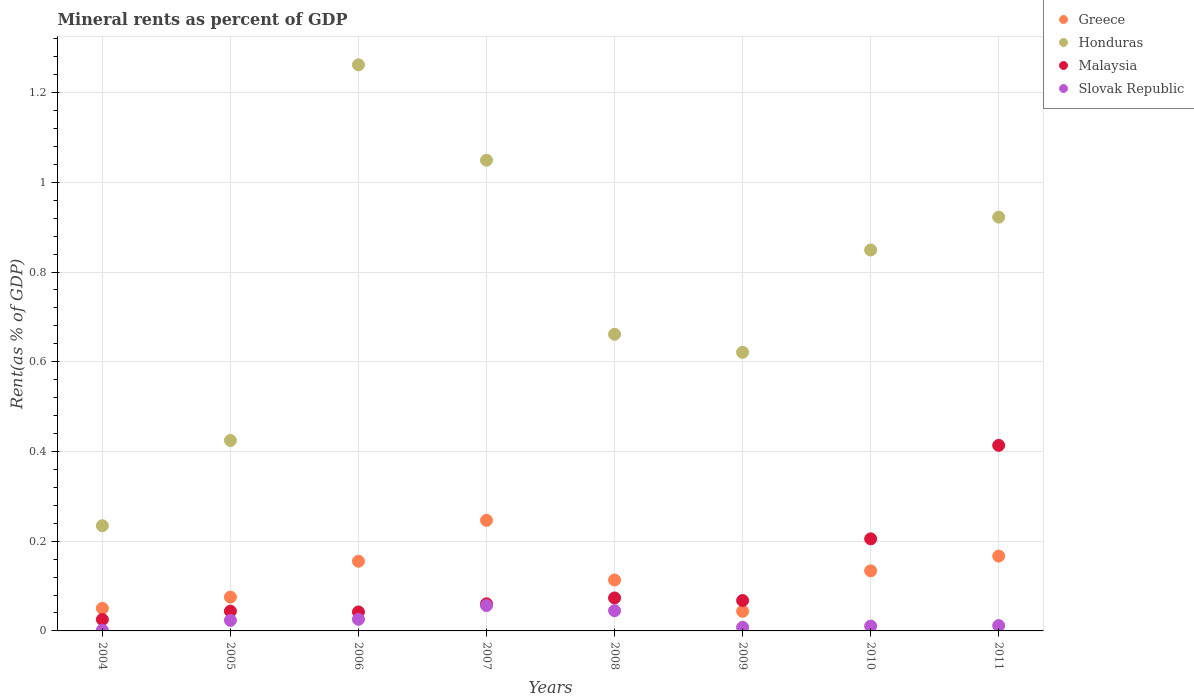How many different coloured dotlines are there?
Provide a succinct answer. 4. What is the mineral rent in Slovak Republic in 2009?
Offer a terse response. 0.01. Across all years, what is the maximum mineral rent in Greece?
Ensure brevity in your answer.  0.25. Across all years, what is the minimum mineral rent in Greece?
Offer a terse response. 0.04. In which year was the mineral rent in Slovak Republic minimum?
Give a very brief answer. 2004. What is the total mineral rent in Slovak Republic in the graph?
Your answer should be very brief. 0.18. What is the difference between the mineral rent in Honduras in 2004 and that in 2006?
Provide a short and direct response. -1.03. What is the difference between the mineral rent in Malaysia in 2011 and the mineral rent in Greece in 2005?
Your answer should be compact. 0.34. What is the average mineral rent in Honduras per year?
Keep it short and to the point. 0.75. In the year 2005, what is the difference between the mineral rent in Slovak Republic and mineral rent in Malaysia?
Provide a short and direct response. -0.02. What is the ratio of the mineral rent in Honduras in 2005 to that in 2007?
Offer a terse response. 0.4. Is the mineral rent in Malaysia in 2004 less than that in 2011?
Give a very brief answer. Yes. Is the difference between the mineral rent in Slovak Republic in 2008 and 2011 greater than the difference between the mineral rent in Malaysia in 2008 and 2011?
Keep it short and to the point. Yes. What is the difference between the highest and the second highest mineral rent in Honduras?
Your answer should be compact. 0.21. What is the difference between the highest and the lowest mineral rent in Malaysia?
Give a very brief answer. 0.39. Is it the case that in every year, the sum of the mineral rent in Malaysia and mineral rent in Slovak Republic  is greater than the sum of mineral rent in Greece and mineral rent in Honduras?
Keep it short and to the point. No. Does the mineral rent in Greece monotonically increase over the years?
Your response must be concise. No. Is the mineral rent in Greece strictly less than the mineral rent in Honduras over the years?
Provide a succinct answer. Yes. How many dotlines are there?
Provide a short and direct response. 4. What is the difference between two consecutive major ticks on the Y-axis?
Offer a terse response. 0.2. Are the values on the major ticks of Y-axis written in scientific E-notation?
Your response must be concise. No. Does the graph contain any zero values?
Provide a short and direct response. No. Does the graph contain grids?
Provide a short and direct response. Yes. Where does the legend appear in the graph?
Provide a succinct answer. Top right. How are the legend labels stacked?
Your answer should be very brief. Vertical. What is the title of the graph?
Provide a short and direct response. Mineral rents as percent of GDP. Does "Iran" appear as one of the legend labels in the graph?
Keep it short and to the point. No. What is the label or title of the Y-axis?
Give a very brief answer. Rent(as % of GDP). What is the Rent(as % of GDP) in Greece in 2004?
Your answer should be very brief. 0.05. What is the Rent(as % of GDP) in Honduras in 2004?
Give a very brief answer. 0.23. What is the Rent(as % of GDP) in Malaysia in 2004?
Provide a short and direct response. 0.03. What is the Rent(as % of GDP) of Slovak Republic in 2004?
Provide a short and direct response. 0. What is the Rent(as % of GDP) in Greece in 2005?
Your response must be concise. 0.08. What is the Rent(as % of GDP) in Honduras in 2005?
Offer a very short reply. 0.42. What is the Rent(as % of GDP) of Malaysia in 2005?
Provide a short and direct response. 0.04. What is the Rent(as % of GDP) in Slovak Republic in 2005?
Provide a succinct answer. 0.02. What is the Rent(as % of GDP) of Greece in 2006?
Keep it short and to the point. 0.16. What is the Rent(as % of GDP) in Honduras in 2006?
Give a very brief answer. 1.26. What is the Rent(as % of GDP) of Malaysia in 2006?
Your answer should be compact. 0.04. What is the Rent(as % of GDP) of Slovak Republic in 2006?
Provide a short and direct response. 0.03. What is the Rent(as % of GDP) of Greece in 2007?
Your answer should be compact. 0.25. What is the Rent(as % of GDP) in Honduras in 2007?
Provide a succinct answer. 1.05. What is the Rent(as % of GDP) of Malaysia in 2007?
Your response must be concise. 0.06. What is the Rent(as % of GDP) of Slovak Republic in 2007?
Offer a very short reply. 0.06. What is the Rent(as % of GDP) of Greece in 2008?
Give a very brief answer. 0.11. What is the Rent(as % of GDP) of Honduras in 2008?
Your answer should be very brief. 0.66. What is the Rent(as % of GDP) in Malaysia in 2008?
Ensure brevity in your answer.  0.07. What is the Rent(as % of GDP) in Slovak Republic in 2008?
Keep it short and to the point. 0.05. What is the Rent(as % of GDP) in Greece in 2009?
Your answer should be very brief. 0.04. What is the Rent(as % of GDP) in Honduras in 2009?
Your response must be concise. 0.62. What is the Rent(as % of GDP) of Malaysia in 2009?
Provide a succinct answer. 0.07. What is the Rent(as % of GDP) in Slovak Republic in 2009?
Your answer should be very brief. 0.01. What is the Rent(as % of GDP) of Greece in 2010?
Ensure brevity in your answer.  0.13. What is the Rent(as % of GDP) in Honduras in 2010?
Give a very brief answer. 0.85. What is the Rent(as % of GDP) of Malaysia in 2010?
Provide a succinct answer. 0.21. What is the Rent(as % of GDP) in Slovak Republic in 2010?
Your response must be concise. 0.01. What is the Rent(as % of GDP) of Greece in 2011?
Give a very brief answer. 0.17. What is the Rent(as % of GDP) of Honduras in 2011?
Offer a very short reply. 0.92. What is the Rent(as % of GDP) of Malaysia in 2011?
Your answer should be compact. 0.41. What is the Rent(as % of GDP) of Slovak Republic in 2011?
Make the answer very short. 0.01. Across all years, what is the maximum Rent(as % of GDP) of Greece?
Offer a terse response. 0.25. Across all years, what is the maximum Rent(as % of GDP) of Honduras?
Ensure brevity in your answer.  1.26. Across all years, what is the maximum Rent(as % of GDP) in Malaysia?
Your answer should be compact. 0.41. Across all years, what is the maximum Rent(as % of GDP) in Slovak Republic?
Provide a succinct answer. 0.06. Across all years, what is the minimum Rent(as % of GDP) in Greece?
Your response must be concise. 0.04. Across all years, what is the minimum Rent(as % of GDP) of Honduras?
Keep it short and to the point. 0.23. Across all years, what is the minimum Rent(as % of GDP) of Malaysia?
Your answer should be very brief. 0.03. Across all years, what is the minimum Rent(as % of GDP) of Slovak Republic?
Keep it short and to the point. 0. What is the total Rent(as % of GDP) in Greece in the graph?
Ensure brevity in your answer.  0.99. What is the total Rent(as % of GDP) in Honduras in the graph?
Provide a short and direct response. 6.02. What is the total Rent(as % of GDP) of Malaysia in the graph?
Your answer should be compact. 0.93. What is the total Rent(as % of GDP) in Slovak Republic in the graph?
Provide a short and direct response. 0.18. What is the difference between the Rent(as % of GDP) of Greece in 2004 and that in 2005?
Offer a terse response. -0.03. What is the difference between the Rent(as % of GDP) of Honduras in 2004 and that in 2005?
Offer a very short reply. -0.19. What is the difference between the Rent(as % of GDP) of Malaysia in 2004 and that in 2005?
Offer a very short reply. -0.02. What is the difference between the Rent(as % of GDP) of Slovak Republic in 2004 and that in 2005?
Give a very brief answer. -0.02. What is the difference between the Rent(as % of GDP) of Greece in 2004 and that in 2006?
Provide a short and direct response. -0.1. What is the difference between the Rent(as % of GDP) in Honduras in 2004 and that in 2006?
Offer a terse response. -1.03. What is the difference between the Rent(as % of GDP) in Malaysia in 2004 and that in 2006?
Make the answer very short. -0.02. What is the difference between the Rent(as % of GDP) in Slovak Republic in 2004 and that in 2006?
Keep it short and to the point. -0.02. What is the difference between the Rent(as % of GDP) of Greece in 2004 and that in 2007?
Give a very brief answer. -0.2. What is the difference between the Rent(as % of GDP) in Honduras in 2004 and that in 2007?
Offer a very short reply. -0.81. What is the difference between the Rent(as % of GDP) of Malaysia in 2004 and that in 2007?
Offer a very short reply. -0.04. What is the difference between the Rent(as % of GDP) in Slovak Republic in 2004 and that in 2007?
Your answer should be very brief. -0.06. What is the difference between the Rent(as % of GDP) of Greece in 2004 and that in 2008?
Keep it short and to the point. -0.06. What is the difference between the Rent(as % of GDP) in Honduras in 2004 and that in 2008?
Offer a terse response. -0.43. What is the difference between the Rent(as % of GDP) of Malaysia in 2004 and that in 2008?
Your answer should be very brief. -0.05. What is the difference between the Rent(as % of GDP) of Slovak Republic in 2004 and that in 2008?
Provide a succinct answer. -0.04. What is the difference between the Rent(as % of GDP) in Greece in 2004 and that in 2009?
Offer a terse response. 0.01. What is the difference between the Rent(as % of GDP) of Honduras in 2004 and that in 2009?
Give a very brief answer. -0.39. What is the difference between the Rent(as % of GDP) of Malaysia in 2004 and that in 2009?
Keep it short and to the point. -0.04. What is the difference between the Rent(as % of GDP) in Slovak Republic in 2004 and that in 2009?
Offer a very short reply. -0.01. What is the difference between the Rent(as % of GDP) in Greece in 2004 and that in 2010?
Offer a terse response. -0.08. What is the difference between the Rent(as % of GDP) in Honduras in 2004 and that in 2010?
Provide a succinct answer. -0.61. What is the difference between the Rent(as % of GDP) of Malaysia in 2004 and that in 2010?
Your answer should be compact. -0.18. What is the difference between the Rent(as % of GDP) in Slovak Republic in 2004 and that in 2010?
Your answer should be very brief. -0.01. What is the difference between the Rent(as % of GDP) in Greece in 2004 and that in 2011?
Provide a short and direct response. -0.12. What is the difference between the Rent(as % of GDP) in Honduras in 2004 and that in 2011?
Keep it short and to the point. -0.69. What is the difference between the Rent(as % of GDP) of Malaysia in 2004 and that in 2011?
Give a very brief answer. -0.39. What is the difference between the Rent(as % of GDP) of Slovak Republic in 2004 and that in 2011?
Provide a succinct answer. -0.01. What is the difference between the Rent(as % of GDP) in Greece in 2005 and that in 2006?
Your response must be concise. -0.08. What is the difference between the Rent(as % of GDP) in Honduras in 2005 and that in 2006?
Your answer should be very brief. -0.84. What is the difference between the Rent(as % of GDP) of Malaysia in 2005 and that in 2006?
Give a very brief answer. 0. What is the difference between the Rent(as % of GDP) of Slovak Republic in 2005 and that in 2006?
Provide a succinct answer. -0. What is the difference between the Rent(as % of GDP) in Greece in 2005 and that in 2007?
Make the answer very short. -0.17. What is the difference between the Rent(as % of GDP) of Honduras in 2005 and that in 2007?
Ensure brevity in your answer.  -0.62. What is the difference between the Rent(as % of GDP) of Malaysia in 2005 and that in 2007?
Provide a succinct answer. -0.02. What is the difference between the Rent(as % of GDP) in Slovak Republic in 2005 and that in 2007?
Your answer should be compact. -0.03. What is the difference between the Rent(as % of GDP) in Greece in 2005 and that in 2008?
Keep it short and to the point. -0.04. What is the difference between the Rent(as % of GDP) of Honduras in 2005 and that in 2008?
Your answer should be very brief. -0.24. What is the difference between the Rent(as % of GDP) in Malaysia in 2005 and that in 2008?
Offer a terse response. -0.03. What is the difference between the Rent(as % of GDP) of Slovak Republic in 2005 and that in 2008?
Your answer should be very brief. -0.02. What is the difference between the Rent(as % of GDP) in Greece in 2005 and that in 2009?
Provide a short and direct response. 0.03. What is the difference between the Rent(as % of GDP) in Honduras in 2005 and that in 2009?
Ensure brevity in your answer.  -0.2. What is the difference between the Rent(as % of GDP) of Malaysia in 2005 and that in 2009?
Offer a very short reply. -0.02. What is the difference between the Rent(as % of GDP) of Slovak Republic in 2005 and that in 2009?
Make the answer very short. 0.02. What is the difference between the Rent(as % of GDP) in Greece in 2005 and that in 2010?
Keep it short and to the point. -0.06. What is the difference between the Rent(as % of GDP) of Honduras in 2005 and that in 2010?
Your answer should be very brief. -0.42. What is the difference between the Rent(as % of GDP) in Malaysia in 2005 and that in 2010?
Your answer should be very brief. -0.16. What is the difference between the Rent(as % of GDP) in Slovak Republic in 2005 and that in 2010?
Your answer should be compact. 0.01. What is the difference between the Rent(as % of GDP) in Greece in 2005 and that in 2011?
Provide a short and direct response. -0.09. What is the difference between the Rent(as % of GDP) in Honduras in 2005 and that in 2011?
Offer a very short reply. -0.5. What is the difference between the Rent(as % of GDP) in Malaysia in 2005 and that in 2011?
Your response must be concise. -0.37. What is the difference between the Rent(as % of GDP) in Slovak Republic in 2005 and that in 2011?
Your answer should be compact. 0.01. What is the difference between the Rent(as % of GDP) in Greece in 2006 and that in 2007?
Make the answer very short. -0.09. What is the difference between the Rent(as % of GDP) in Honduras in 2006 and that in 2007?
Provide a succinct answer. 0.21. What is the difference between the Rent(as % of GDP) in Malaysia in 2006 and that in 2007?
Ensure brevity in your answer.  -0.02. What is the difference between the Rent(as % of GDP) in Slovak Republic in 2006 and that in 2007?
Provide a succinct answer. -0.03. What is the difference between the Rent(as % of GDP) in Greece in 2006 and that in 2008?
Provide a short and direct response. 0.04. What is the difference between the Rent(as % of GDP) in Honduras in 2006 and that in 2008?
Ensure brevity in your answer.  0.6. What is the difference between the Rent(as % of GDP) in Malaysia in 2006 and that in 2008?
Ensure brevity in your answer.  -0.03. What is the difference between the Rent(as % of GDP) of Slovak Republic in 2006 and that in 2008?
Your answer should be compact. -0.02. What is the difference between the Rent(as % of GDP) of Greece in 2006 and that in 2009?
Ensure brevity in your answer.  0.11. What is the difference between the Rent(as % of GDP) in Honduras in 2006 and that in 2009?
Your response must be concise. 0.64. What is the difference between the Rent(as % of GDP) of Malaysia in 2006 and that in 2009?
Provide a succinct answer. -0.03. What is the difference between the Rent(as % of GDP) of Slovak Republic in 2006 and that in 2009?
Ensure brevity in your answer.  0.02. What is the difference between the Rent(as % of GDP) of Greece in 2006 and that in 2010?
Provide a succinct answer. 0.02. What is the difference between the Rent(as % of GDP) in Honduras in 2006 and that in 2010?
Provide a succinct answer. 0.41. What is the difference between the Rent(as % of GDP) in Malaysia in 2006 and that in 2010?
Make the answer very short. -0.16. What is the difference between the Rent(as % of GDP) in Slovak Republic in 2006 and that in 2010?
Your response must be concise. 0.02. What is the difference between the Rent(as % of GDP) of Greece in 2006 and that in 2011?
Give a very brief answer. -0.01. What is the difference between the Rent(as % of GDP) of Honduras in 2006 and that in 2011?
Your response must be concise. 0.34. What is the difference between the Rent(as % of GDP) in Malaysia in 2006 and that in 2011?
Your response must be concise. -0.37. What is the difference between the Rent(as % of GDP) in Slovak Republic in 2006 and that in 2011?
Offer a terse response. 0.01. What is the difference between the Rent(as % of GDP) in Greece in 2007 and that in 2008?
Provide a short and direct response. 0.13. What is the difference between the Rent(as % of GDP) of Honduras in 2007 and that in 2008?
Provide a succinct answer. 0.39. What is the difference between the Rent(as % of GDP) of Malaysia in 2007 and that in 2008?
Keep it short and to the point. -0.01. What is the difference between the Rent(as % of GDP) in Slovak Republic in 2007 and that in 2008?
Offer a terse response. 0.01. What is the difference between the Rent(as % of GDP) in Greece in 2007 and that in 2009?
Offer a very short reply. 0.2. What is the difference between the Rent(as % of GDP) in Honduras in 2007 and that in 2009?
Give a very brief answer. 0.43. What is the difference between the Rent(as % of GDP) of Malaysia in 2007 and that in 2009?
Your response must be concise. -0.01. What is the difference between the Rent(as % of GDP) in Slovak Republic in 2007 and that in 2009?
Your response must be concise. 0.05. What is the difference between the Rent(as % of GDP) of Greece in 2007 and that in 2010?
Your answer should be very brief. 0.11. What is the difference between the Rent(as % of GDP) of Honduras in 2007 and that in 2010?
Provide a short and direct response. 0.2. What is the difference between the Rent(as % of GDP) of Malaysia in 2007 and that in 2010?
Make the answer very short. -0.14. What is the difference between the Rent(as % of GDP) in Slovak Republic in 2007 and that in 2010?
Provide a succinct answer. 0.05. What is the difference between the Rent(as % of GDP) of Greece in 2007 and that in 2011?
Make the answer very short. 0.08. What is the difference between the Rent(as % of GDP) of Honduras in 2007 and that in 2011?
Provide a short and direct response. 0.13. What is the difference between the Rent(as % of GDP) of Malaysia in 2007 and that in 2011?
Offer a terse response. -0.35. What is the difference between the Rent(as % of GDP) in Slovak Republic in 2007 and that in 2011?
Provide a succinct answer. 0.04. What is the difference between the Rent(as % of GDP) in Greece in 2008 and that in 2009?
Your response must be concise. 0.07. What is the difference between the Rent(as % of GDP) of Honduras in 2008 and that in 2009?
Provide a succinct answer. 0.04. What is the difference between the Rent(as % of GDP) of Malaysia in 2008 and that in 2009?
Offer a terse response. 0.01. What is the difference between the Rent(as % of GDP) in Slovak Republic in 2008 and that in 2009?
Your answer should be compact. 0.04. What is the difference between the Rent(as % of GDP) in Greece in 2008 and that in 2010?
Your answer should be very brief. -0.02. What is the difference between the Rent(as % of GDP) in Honduras in 2008 and that in 2010?
Offer a terse response. -0.19. What is the difference between the Rent(as % of GDP) in Malaysia in 2008 and that in 2010?
Offer a terse response. -0.13. What is the difference between the Rent(as % of GDP) of Slovak Republic in 2008 and that in 2010?
Provide a succinct answer. 0.03. What is the difference between the Rent(as % of GDP) of Greece in 2008 and that in 2011?
Offer a terse response. -0.05. What is the difference between the Rent(as % of GDP) in Honduras in 2008 and that in 2011?
Your answer should be very brief. -0.26. What is the difference between the Rent(as % of GDP) of Malaysia in 2008 and that in 2011?
Provide a short and direct response. -0.34. What is the difference between the Rent(as % of GDP) in Greece in 2009 and that in 2010?
Make the answer very short. -0.09. What is the difference between the Rent(as % of GDP) in Honduras in 2009 and that in 2010?
Provide a short and direct response. -0.23. What is the difference between the Rent(as % of GDP) of Malaysia in 2009 and that in 2010?
Your answer should be very brief. -0.14. What is the difference between the Rent(as % of GDP) in Slovak Republic in 2009 and that in 2010?
Ensure brevity in your answer.  -0. What is the difference between the Rent(as % of GDP) in Greece in 2009 and that in 2011?
Your answer should be compact. -0.12. What is the difference between the Rent(as % of GDP) in Honduras in 2009 and that in 2011?
Your answer should be very brief. -0.3. What is the difference between the Rent(as % of GDP) of Malaysia in 2009 and that in 2011?
Offer a very short reply. -0.35. What is the difference between the Rent(as % of GDP) in Slovak Republic in 2009 and that in 2011?
Provide a short and direct response. -0. What is the difference between the Rent(as % of GDP) in Greece in 2010 and that in 2011?
Your response must be concise. -0.03. What is the difference between the Rent(as % of GDP) in Honduras in 2010 and that in 2011?
Your answer should be compact. -0.07. What is the difference between the Rent(as % of GDP) in Malaysia in 2010 and that in 2011?
Offer a very short reply. -0.21. What is the difference between the Rent(as % of GDP) in Slovak Republic in 2010 and that in 2011?
Ensure brevity in your answer.  -0. What is the difference between the Rent(as % of GDP) of Greece in 2004 and the Rent(as % of GDP) of Honduras in 2005?
Provide a short and direct response. -0.37. What is the difference between the Rent(as % of GDP) in Greece in 2004 and the Rent(as % of GDP) in Malaysia in 2005?
Provide a succinct answer. 0.01. What is the difference between the Rent(as % of GDP) of Greece in 2004 and the Rent(as % of GDP) of Slovak Republic in 2005?
Your answer should be compact. 0.03. What is the difference between the Rent(as % of GDP) of Honduras in 2004 and the Rent(as % of GDP) of Malaysia in 2005?
Give a very brief answer. 0.19. What is the difference between the Rent(as % of GDP) of Honduras in 2004 and the Rent(as % of GDP) of Slovak Republic in 2005?
Offer a very short reply. 0.21. What is the difference between the Rent(as % of GDP) of Malaysia in 2004 and the Rent(as % of GDP) of Slovak Republic in 2005?
Your response must be concise. 0. What is the difference between the Rent(as % of GDP) of Greece in 2004 and the Rent(as % of GDP) of Honduras in 2006?
Provide a succinct answer. -1.21. What is the difference between the Rent(as % of GDP) of Greece in 2004 and the Rent(as % of GDP) of Malaysia in 2006?
Your response must be concise. 0.01. What is the difference between the Rent(as % of GDP) in Greece in 2004 and the Rent(as % of GDP) in Slovak Republic in 2006?
Ensure brevity in your answer.  0.02. What is the difference between the Rent(as % of GDP) of Honduras in 2004 and the Rent(as % of GDP) of Malaysia in 2006?
Your answer should be compact. 0.19. What is the difference between the Rent(as % of GDP) in Honduras in 2004 and the Rent(as % of GDP) in Slovak Republic in 2006?
Offer a very short reply. 0.21. What is the difference between the Rent(as % of GDP) of Malaysia in 2004 and the Rent(as % of GDP) of Slovak Republic in 2006?
Keep it short and to the point. -0. What is the difference between the Rent(as % of GDP) of Greece in 2004 and the Rent(as % of GDP) of Honduras in 2007?
Your answer should be compact. -1. What is the difference between the Rent(as % of GDP) of Greece in 2004 and the Rent(as % of GDP) of Malaysia in 2007?
Offer a very short reply. -0.01. What is the difference between the Rent(as % of GDP) in Greece in 2004 and the Rent(as % of GDP) in Slovak Republic in 2007?
Your answer should be compact. -0.01. What is the difference between the Rent(as % of GDP) of Honduras in 2004 and the Rent(as % of GDP) of Malaysia in 2007?
Offer a very short reply. 0.17. What is the difference between the Rent(as % of GDP) of Honduras in 2004 and the Rent(as % of GDP) of Slovak Republic in 2007?
Offer a very short reply. 0.18. What is the difference between the Rent(as % of GDP) of Malaysia in 2004 and the Rent(as % of GDP) of Slovak Republic in 2007?
Make the answer very short. -0.03. What is the difference between the Rent(as % of GDP) in Greece in 2004 and the Rent(as % of GDP) in Honduras in 2008?
Your response must be concise. -0.61. What is the difference between the Rent(as % of GDP) of Greece in 2004 and the Rent(as % of GDP) of Malaysia in 2008?
Give a very brief answer. -0.02. What is the difference between the Rent(as % of GDP) in Greece in 2004 and the Rent(as % of GDP) in Slovak Republic in 2008?
Offer a terse response. 0.01. What is the difference between the Rent(as % of GDP) of Honduras in 2004 and the Rent(as % of GDP) of Malaysia in 2008?
Offer a terse response. 0.16. What is the difference between the Rent(as % of GDP) in Honduras in 2004 and the Rent(as % of GDP) in Slovak Republic in 2008?
Your response must be concise. 0.19. What is the difference between the Rent(as % of GDP) in Malaysia in 2004 and the Rent(as % of GDP) in Slovak Republic in 2008?
Ensure brevity in your answer.  -0.02. What is the difference between the Rent(as % of GDP) of Greece in 2004 and the Rent(as % of GDP) of Honduras in 2009?
Give a very brief answer. -0.57. What is the difference between the Rent(as % of GDP) of Greece in 2004 and the Rent(as % of GDP) of Malaysia in 2009?
Offer a terse response. -0.02. What is the difference between the Rent(as % of GDP) in Greece in 2004 and the Rent(as % of GDP) in Slovak Republic in 2009?
Your answer should be very brief. 0.04. What is the difference between the Rent(as % of GDP) in Honduras in 2004 and the Rent(as % of GDP) in Malaysia in 2009?
Your answer should be compact. 0.17. What is the difference between the Rent(as % of GDP) in Honduras in 2004 and the Rent(as % of GDP) in Slovak Republic in 2009?
Your answer should be compact. 0.23. What is the difference between the Rent(as % of GDP) of Malaysia in 2004 and the Rent(as % of GDP) of Slovak Republic in 2009?
Provide a succinct answer. 0.02. What is the difference between the Rent(as % of GDP) in Greece in 2004 and the Rent(as % of GDP) in Honduras in 2010?
Offer a very short reply. -0.8. What is the difference between the Rent(as % of GDP) of Greece in 2004 and the Rent(as % of GDP) of Malaysia in 2010?
Your response must be concise. -0.15. What is the difference between the Rent(as % of GDP) in Greece in 2004 and the Rent(as % of GDP) in Slovak Republic in 2010?
Offer a terse response. 0.04. What is the difference between the Rent(as % of GDP) in Honduras in 2004 and the Rent(as % of GDP) in Malaysia in 2010?
Make the answer very short. 0.03. What is the difference between the Rent(as % of GDP) in Honduras in 2004 and the Rent(as % of GDP) in Slovak Republic in 2010?
Provide a short and direct response. 0.22. What is the difference between the Rent(as % of GDP) in Malaysia in 2004 and the Rent(as % of GDP) in Slovak Republic in 2010?
Offer a terse response. 0.01. What is the difference between the Rent(as % of GDP) in Greece in 2004 and the Rent(as % of GDP) in Honduras in 2011?
Provide a short and direct response. -0.87. What is the difference between the Rent(as % of GDP) of Greece in 2004 and the Rent(as % of GDP) of Malaysia in 2011?
Provide a succinct answer. -0.36. What is the difference between the Rent(as % of GDP) of Greece in 2004 and the Rent(as % of GDP) of Slovak Republic in 2011?
Ensure brevity in your answer.  0.04. What is the difference between the Rent(as % of GDP) in Honduras in 2004 and the Rent(as % of GDP) in Malaysia in 2011?
Your answer should be compact. -0.18. What is the difference between the Rent(as % of GDP) of Honduras in 2004 and the Rent(as % of GDP) of Slovak Republic in 2011?
Provide a succinct answer. 0.22. What is the difference between the Rent(as % of GDP) of Malaysia in 2004 and the Rent(as % of GDP) of Slovak Republic in 2011?
Provide a succinct answer. 0.01. What is the difference between the Rent(as % of GDP) of Greece in 2005 and the Rent(as % of GDP) of Honduras in 2006?
Your answer should be very brief. -1.19. What is the difference between the Rent(as % of GDP) of Greece in 2005 and the Rent(as % of GDP) of Malaysia in 2006?
Offer a terse response. 0.03. What is the difference between the Rent(as % of GDP) in Greece in 2005 and the Rent(as % of GDP) in Slovak Republic in 2006?
Your answer should be very brief. 0.05. What is the difference between the Rent(as % of GDP) in Honduras in 2005 and the Rent(as % of GDP) in Malaysia in 2006?
Offer a very short reply. 0.38. What is the difference between the Rent(as % of GDP) of Honduras in 2005 and the Rent(as % of GDP) of Slovak Republic in 2006?
Keep it short and to the point. 0.4. What is the difference between the Rent(as % of GDP) of Malaysia in 2005 and the Rent(as % of GDP) of Slovak Republic in 2006?
Provide a short and direct response. 0.02. What is the difference between the Rent(as % of GDP) of Greece in 2005 and the Rent(as % of GDP) of Honduras in 2007?
Your answer should be compact. -0.97. What is the difference between the Rent(as % of GDP) of Greece in 2005 and the Rent(as % of GDP) of Malaysia in 2007?
Your answer should be compact. 0.01. What is the difference between the Rent(as % of GDP) of Greece in 2005 and the Rent(as % of GDP) of Slovak Republic in 2007?
Your answer should be very brief. 0.02. What is the difference between the Rent(as % of GDP) in Honduras in 2005 and the Rent(as % of GDP) in Malaysia in 2007?
Offer a terse response. 0.36. What is the difference between the Rent(as % of GDP) in Honduras in 2005 and the Rent(as % of GDP) in Slovak Republic in 2007?
Your answer should be very brief. 0.37. What is the difference between the Rent(as % of GDP) of Malaysia in 2005 and the Rent(as % of GDP) of Slovak Republic in 2007?
Ensure brevity in your answer.  -0.01. What is the difference between the Rent(as % of GDP) of Greece in 2005 and the Rent(as % of GDP) of Honduras in 2008?
Keep it short and to the point. -0.59. What is the difference between the Rent(as % of GDP) of Greece in 2005 and the Rent(as % of GDP) of Malaysia in 2008?
Make the answer very short. 0. What is the difference between the Rent(as % of GDP) of Greece in 2005 and the Rent(as % of GDP) of Slovak Republic in 2008?
Provide a short and direct response. 0.03. What is the difference between the Rent(as % of GDP) in Honduras in 2005 and the Rent(as % of GDP) in Malaysia in 2008?
Ensure brevity in your answer.  0.35. What is the difference between the Rent(as % of GDP) of Honduras in 2005 and the Rent(as % of GDP) of Slovak Republic in 2008?
Ensure brevity in your answer.  0.38. What is the difference between the Rent(as % of GDP) in Malaysia in 2005 and the Rent(as % of GDP) in Slovak Republic in 2008?
Ensure brevity in your answer.  -0. What is the difference between the Rent(as % of GDP) of Greece in 2005 and the Rent(as % of GDP) of Honduras in 2009?
Your response must be concise. -0.55. What is the difference between the Rent(as % of GDP) of Greece in 2005 and the Rent(as % of GDP) of Malaysia in 2009?
Make the answer very short. 0.01. What is the difference between the Rent(as % of GDP) in Greece in 2005 and the Rent(as % of GDP) in Slovak Republic in 2009?
Offer a very short reply. 0.07. What is the difference between the Rent(as % of GDP) of Honduras in 2005 and the Rent(as % of GDP) of Malaysia in 2009?
Give a very brief answer. 0.36. What is the difference between the Rent(as % of GDP) of Honduras in 2005 and the Rent(as % of GDP) of Slovak Republic in 2009?
Your answer should be compact. 0.42. What is the difference between the Rent(as % of GDP) in Malaysia in 2005 and the Rent(as % of GDP) in Slovak Republic in 2009?
Make the answer very short. 0.04. What is the difference between the Rent(as % of GDP) in Greece in 2005 and the Rent(as % of GDP) in Honduras in 2010?
Give a very brief answer. -0.77. What is the difference between the Rent(as % of GDP) of Greece in 2005 and the Rent(as % of GDP) of Malaysia in 2010?
Your answer should be compact. -0.13. What is the difference between the Rent(as % of GDP) of Greece in 2005 and the Rent(as % of GDP) of Slovak Republic in 2010?
Your answer should be very brief. 0.06. What is the difference between the Rent(as % of GDP) of Honduras in 2005 and the Rent(as % of GDP) of Malaysia in 2010?
Provide a succinct answer. 0.22. What is the difference between the Rent(as % of GDP) in Honduras in 2005 and the Rent(as % of GDP) in Slovak Republic in 2010?
Offer a terse response. 0.41. What is the difference between the Rent(as % of GDP) of Malaysia in 2005 and the Rent(as % of GDP) of Slovak Republic in 2010?
Keep it short and to the point. 0.03. What is the difference between the Rent(as % of GDP) in Greece in 2005 and the Rent(as % of GDP) in Honduras in 2011?
Offer a terse response. -0.85. What is the difference between the Rent(as % of GDP) of Greece in 2005 and the Rent(as % of GDP) of Malaysia in 2011?
Your answer should be very brief. -0.34. What is the difference between the Rent(as % of GDP) in Greece in 2005 and the Rent(as % of GDP) in Slovak Republic in 2011?
Your answer should be very brief. 0.06. What is the difference between the Rent(as % of GDP) of Honduras in 2005 and the Rent(as % of GDP) of Malaysia in 2011?
Your response must be concise. 0.01. What is the difference between the Rent(as % of GDP) in Honduras in 2005 and the Rent(as % of GDP) in Slovak Republic in 2011?
Keep it short and to the point. 0.41. What is the difference between the Rent(as % of GDP) of Malaysia in 2005 and the Rent(as % of GDP) of Slovak Republic in 2011?
Offer a very short reply. 0.03. What is the difference between the Rent(as % of GDP) of Greece in 2006 and the Rent(as % of GDP) of Honduras in 2007?
Your answer should be very brief. -0.89. What is the difference between the Rent(as % of GDP) of Greece in 2006 and the Rent(as % of GDP) of Malaysia in 2007?
Provide a succinct answer. 0.09. What is the difference between the Rent(as % of GDP) of Greece in 2006 and the Rent(as % of GDP) of Slovak Republic in 2007?
Your answer should be very brief. 0.1. What is the difference between the Rent(as % of GDP) in Honduras in 2006 and the Rent(as % of GDP) in Malaysia in 2007?
Your answer should be very brief. 1.2. What is the difference between the Rent(as % of GDP) in Honduras in 2006 and the Rent(as % of GDP) in Slovak Republic in 2007?
Your answer should be very brief. 1.21. What is the difference between the Rent(as % of GDP) of Malaysia in 2006 and the Rent(as % of GDP) of Slovak Republic in 2007?
Ensure brevity in your answer.  -0.01. What is the difference between the Rent(as % of GDP) of Greece in 2006 and the Rent(as % of GDP) of Honduras in 2008?
Offer a very short reply. -0.51. What is the difference between the Rent(as % of GDP) in Greece in 2006 and the Rent(as % of GDP) in Malaysia in 2008?
Give a very brief answer. 0.08. What is the difference between the Rent(as % of GDP) of Greece in 2006 and the Rent(as % of GDP) of Slovak Republic in 2008?
Provide a short and direct response. 0.11. What is the difference between the Rent(as % of GDP) of Honduras in 2006 and the Rent(as % of GDP) of Malaysia in 2008?
Provide a succinct answer. 1.19. What is the difference between the Rent(as % of GDP) of Honduras in 2006 and the Rent(as % of GDP) of Slovak Republic in 2008?
Give a very brief answer. 1.22. What is the difference between the Rent(as % of GDP) in Malaysia in 2006 and the Rent(as % of GDP) in Slovak Republic in 2008?
Ensure brevity in your answer.  -0. What is the difference between the Rent(as % of GDP) of Greece in 2006 and the Rent(as % of GDP) of Honduras in 2009?
Offer a terse response. -0.47. What is the difference between the Rent(as % of GDP) of Greece in 2006 and the Rent(as % of GDP) of Malaysia in 2009?
Provide a short and direct response. 0.09. What is the difference between the Rent(as % of GDP) in Greece in 2006 and the Rent(as % of GDP) in Slovak Republic in 2009?
Give a very brief answer. 0.15. What is the difference between the Rent(as % of GDP) in Honduras in 2006 and the Rent(as % of GDP) in Malaysia in 2009?
Offer a very short reply. 1.19. What is the difference between the Rent(as % of GDP) of Honduras in 2006 and the Rent(as % of GDP) of Slovak Republic in 2009?
Offer a terse response. 1.25. What is the difference between the Rent(as % of GDP) of Malaysia in 2006 and the Rent(as % of GDP) of Slovak Republic in 2009?
Provide a succinct answer. 0.03. What is the difference between the Rent(as % of GDP) of Greece in 2006 and the Rent(as % of GDP) of Honduras in 2010?
Provide a succinct answer. -0.69. What is the difference between the Rent(as % of GDP) in Greece in 2006 and the Rent(as % of GDP) in Malaysia in 2010?
Provide a short and direct response. -0.05. What is the difference between the Rent(as % of GDP) in Greece in 2006 and the Rent(as % of GDP) in Slovak Republic in 2010?
Keep it short and to the point. 0.14. What is the difference between the Rent(as % of GDP) of Honduras in 2006 and the Rent(as % of GDP) of Malaysia in 2010?
Your answer should be compact. 1.06. What is the difference between the Rent(as % of GDP) in Honduras in 2006 and the Rent(as % of GDP) in Slovak Republic in 2010?
Provide a succinct answer. 1.25. What is the difference between the Rent(as % of GDP) in Malaysia in 2006 and the Rent(as % of GDP) in Slovak Republic in 2010?
Provide a succinct answer. 0.03. What is the difference between the Rent(as % of GDP) in Greece in 2006 and the Rent(as % of GDP) in Honduras in 2011?
Offer a terse response. -0.77. What is the difference between the Rent(as % of GDP) in Greece in 2006 and the Rent(as % of GDP) in Malaysia in 2011?
Your response must be concise. -0.26. What is the difference between the Rent(as % of GDP) in Greece in 2006 and the Rent(as % of GDP) in Slovak Republic in 2011?
Give a very brief answer. 0.14. What is the difference between the Rent(as % of GDP) in Honduras in 2006 and the Rent(as % of GDP) in Malaysia in 2011?
Offer a terse response. 0.85. What is the difference between the Rent(as % of GDP) of Malaysia in 2006 and the Rent(as % of GDP) of Slovak Republic in 2011?
Provide a succinct answer. 0.03. What is the difference between the Rent(as % of GDP) of Greece in 2007 and the Rent(as % of GDP) of Honduras in 2008?
Make the answer very short. -0.41. What is the difference between the Rent(as % of GDP) in Greece in 2007 and the Rent(as % of GDP) in Malaysia in 2008?
Make the answer very short. 0.17. What is the difference between the Rent(as % of GDP) of Greece in 2007 and the Rent(as % of GDP) of Slovak Republic in 2008?
Offer a very short reply. 0.2. What is the difference between the Rent(as % of GDP) in Honduras in 2007 and the Rent(as % of GDP) in Malaysia in 2008?
Give a very brief answer. 0.98. What is the difference between the Rent(as % of GDP) of Malaysia in 2007 and the Rent(as % of GDP) of Slovak Republic in 2008?
Your response must be concise. 0.02. What is the difference between the Rent(as % of GDP) in Greece in 2007 and the Rent(as % of GDP) in Honduras in 2009?
Provide a short and direct response. -0.37. What is the difference between the Rent(as % of GDP) in Greece in 2007 and the Rent(as % of GDP) in Malaysia in 2009?
Your answer should be very brief. 0.18. What is the difference between the Rent(as % of GDP) in Greece in 2007 and the Rent(as % of GDP) in Slovak Republic in 2009?
Keep it short and to the point. 0.24. What is the difference between the Rent(as % of GDP) of Honduras in 2007 and the Rent(as % of GDP) of Malaysia in 2009?
Offer a terse response. 0.98. What is the difference between the Rent(as % of GDP) of Honduras in 2007 and the Rent(as % of GDP) of Slovak Republic in 2009?
Keep it short and to the point. 1.04. What is the difference between the Rent(as % of GDP) of Malaysia in 2007 and the Rent(as % of GDP) of Slovak Republic in 2009?
Offer a very short reply. 0.05. What is the difference between the Rent(as % of GDP) of Greece in 2007 and the Rent(as % of GDP) of Honduras in 2010?
Your response must be concise. -0.6. What is the difference between the Rent(as % of GDP) in Greece in 2007 and the Rent(as % of GDP) in Malaysia in 2010?
Provide a succinct answer. 0.04. What is the difference between the Rent(as % of GDP) in Greece in 2007 and the Rent(as % of GDP) in Slovak Republic in 2010?
Offer a terse response. 0.24. What is the difference between the Rent(as % of GDP) of Honduras in 2007 and the Rent(as % of GDP) of Malaysia in 2010?
Make the answer very short. 0.84. What is the difference between the Rent(as % of GDP) in Honduras in 2007 and the Rent(as % of GDP) in Slovak Republic in 2010?
Your response must be concise. 1.04. What is the difference between the Rent(as % of GDP) in Malaysia in 2007 and the Rent(as % of GDP) in Slovak Republic in 2010?
Your answer should be compact. 0.05. What is the difference between the Rent(as % of GDP) in Greece in 2007 and the Rent(as % of GDP) in Honduras in 2011?
Your answer should be very brief. -0.68. What is the difference between the Rent(as % of GDP) in Greece in 2007 and the Rent(as % of GDP) in Malaysia in 2011?
Offer a terse response. -0.17. What is the difference between the Rent(as % of GDP) of Greece in 2007 and the Rent(as % of GDP) of Slovak Republic in 2011?
Keep it short and to the point. 0.23. What is the difference between the Rent(as % of GDP) in Honduras in 2007 and the Rent(as % of GDP) in Malaysia in 2011?
Provide a succinct answer. 0.64. What is the difference between the Rent(as % of GDP) of Honduras in 2007 and the Rent(as % of GDP) of Slovak Republic in 2011?
Provide a short and direct response. 1.04. What is the difference between the Rent(as % of GDP) of Malaysia in 2007 and the Rent(as % of GDP) of Slovak Republic in 2011?
Your response must be concise. 0.05. What is the difference between the Rent(as % of GDP) in Greece in 2008 and the Rent(as % of GDP) in Honduras in 2009?
Make the answer very short. -0.51. What is the difference between the Rent(as % of GDP) of Greece in 2008 and the Rent(as % of GDP) of Malaysia in 2009?
Your answer should be very brief. 0.05. What is the difference between the Rent(as % of GDP) in Greece in 2008 and the Rent(as % of GDP) in Slovak Republic in 2009?
Provide a succinct answer. 0.11. What is the difference between the Rent(as % of GDP) in Honduras in 2008 and the Rent(as % of GDP) in Malaysia in 2009?
Offer a terse response. 0.59. What is the difference between the Rent(as % of GDP) of Honduras in 2008 and the Rent(as % of GDP) of Slovak Republic in 2009?
Offer a terse response. 0.65. What is the difference between the Rent(as % of GDP) in Malaysia in 2008 and the Rent(as % of GDP) in Slovak Republic in 2009?
Make the answer very short. 0.07. What is the difference between the Rent(as % of GDP) in Greece in 2008 and the Rent(as % of GDP) in Honduras in 2010?
Offer a very short reply. -0.74. What is the difference between the Rent(as % of GDP) of Greece in 2008 and the Rent(as % of GDP) of Malaysia in 2010?
Give a very brief answer. -0.09. What is the difference between the Rent(as % of GDP) in Greece in 2008 and the Rent(as % of GDP) in Slovak Republic in 2010?
Your answer should be compact. 0.1. What is the difference between the Rent(as % of GDP) of Honduras in 2008 and the Rent(as % of GDP) of Malaysia in 2010?
Offer a terse response. 0.46. What is the difference between the Rent(as % of GDP) in Honduras in 2008 and the Rent(as % of GDP) in Slovak Republic in 2010?
Provide a succinct answer. 0.65. What is the difference between the Rent(as % of GDP) of Malaysia in 2008 and the Rent(as % of GDP) of Slovak Republic in 2010?
Give a very brief answer. 0.06. What is the difference between the Rent(as % of GDP) of Greece in 2008 and the Rent(as % of GDP) of Honduras in 2011?
Provide a succinct answer. -0.81. What is the difference between the Rent(as % of GDP) in Greece in 2008 and the Rent(as % of GDP) in Slovak Republic in 2011?
Keep it short and to the point. 0.1. What is the difference between the Rent(as % of GDP) in Honduras in 2008 and the Rent(as % of GDP) in Malaysia in 2011?
Your response must be concise. 0.25. What is the difference between the Rent(as % of GDP) of Honduras in 2008 and the Rent(as % of GDP) of Slovak Republic in 2011?
Give a very brief answer. 0.65. What is the difference between the Rent(as % of GDP) in Malaysia in 2008 and the Rent(as % of GDP) in Slovak Republic in 2011?
Your response must be concise. 0.06. What is the difference between the Rent(as % of GDP) of Greece in 2009 and the Rent(as % of GDP) of Honduras in 2010?
Give a very brief answer. -0.81. What is the difference between the Rent(as % of GDP) of Greece in 2009 and the Rent(as % of GDP) of Malaysia in 2010?
Provide a succinct answer. -0.16. What is the difference between the Rent(as % of GDP) of Greece in 2009 and the Rent(as % of GDP) of Slovak Republic in 2010?
Keep it short and to the point. 0.03. What is the difference between the Rent(as % of GDP) of Honduras in 2009 and the Rent(as % of GDP) of Malaysia in 2010?
Your answer should be compact. 0.42. What is the difference between the Rent(as % of GDP) of Honduras in 2009 and the Rent(as % of GDP) of Slovak Republic in 2010?
Ensure brevity in your answer.  0.61. What is the difference between the Rent(as % of GDP) of Malaysia in 2009 and the Rent(as % of GDP) of Slovak Republic in 2010?
Your answer should be very brief. 0.06. What is the difference between the Rent(as % of GDP) of Greece in 2009 and the Rent(as % of GDP) of Honduras in 2011?
Provide a succinct answer. -0.88. What is the difference between the Rent(as % of GDP) of Greece in 2009 and the Rent(as % of GDP) of Malaysia in 2011?
Offer a terse response. -0.37. What is the difference between the Rent(as % of GDP) of Greece in 2009 and the Rent(as % of GDP) of Slovak Republic in 2011?
Ensure brevity in your answer.  0.03. What is the difference between the Rent(as % of GDP) of Honduras in 2009 and the Rent(as % of GDP) of Malaysia in 2011?
Your answer should be very brief. 0.21. What is the difference between the Rent(as % of GDP) of Honduras in 2009 and the Rent(as % of GDP) of Slovak Republic in 2011?
Your response must be concise. 0.61. What is the difference between the Rent(as % of GDP) of Malaysia in 2009 and the Rent(as % of GDP) of Slovak Republic in 2011?
Provide a short and direct response. 0.06. What is the difference between the Rent(as % of GDP) of Greece in 2010 and the Rent(as % of GDP) of Honduras in 2011?
Your answer should be compact. -0.79. What is the difference between the Rent(as % of GDP) of Greece in 2010 and the Rent(as % of GDP) of Malaysia in 2011?
Offer a terse response. -0.28. What is the difference between the Rent(as % of GDP) of Greece in 2010 and the Rent(as % of GDP) of Slovak Republic in 2011?
Make the answer very short. 0.12. What is the difference between the Rent(as % of GDP) in Honduras in 2010 and the Rent(as % of GDP) in Malaysia in 2011?
Offer a very short reply. 0.44. What is the difference between the Rent(as % of GDP) of Honduras in 2010 and the Rent(as % of GDP) of Slovak Republic in 2011?
Offer a very short reply. 0.84. What is the difference between the Rent(as % of GDP) of Malaysia in 2010 and the Rent(as % of GDP) of Slovak Republic in 2011?
Ensure brevity in your answer.  0.19. What is the average Rent(as % of GDP) of Greece per year?
Offer a very short reply. 0.12. What is the average Rent(as % of GDP) in Honduras per year?
Keep it short and to the point. 0.75. What is the average Rent(as % of GDP) of Malaysia per year?
Your answer should be compact. 0.12. What is the average Rent(as % of GDP) of Slovak Republic per year?
Your answer should be very brief. 0.02. In the year 2004, what is the difference between the Rent(as % of GDP) of Greece and Rent(as % of GDP) of Honduras?
Keep it short and to the point. -0.18. In the year 2004, what is the difference between the Rent(as % of GDP) in Greece and Rent(as % of GDP) in Malaysia?
Give a very brief answer. 0.02. In the year 2004, what is the difference between the Rent(as % of GDP) in Greece and Rent(as % of GDP) in Slovak Republic?
Your response must be concise. 0.05. In the year 2004, what is the difference between the Rent(as % of GDP) in Honduras and Rent(as % of GDP) in Malaysia?
Keep it short and to the point. 0.21. In the year 2004, what is the difference between the Rent(as % of GDP) of Honduras and Rent(as % of GDP) of Slovak Republic?
Ensure brevity in your answer.  0.23. In the year 2004, what is the difference between the Rent(as % of GDP) in Malaysia and Rent(as % of GDP) in Slovak Republic?
Give a very brief answer. 0.02. In the year 2005, what is the difference between the Rent(as % of GDP) of Greece and Rent(as % of GDP) of Honduras?
Provide a short and direct response. -0.35. In the year 2005, what is the difference between the Rent(as % of GDP) in Greece and Rent(as % of GDP) in Malaysia?
Your answer should be compact. 0.03. In the year 2005, what is the difference between the Rent(as % of GDP) of Greece and Rent(as % of GDP) of Slovak Republic?
Your response must be concise. 0.05. In the year 2005, what is the difference between the Rent(as % of GDP) in Honduras and Rent(as % of GDP) in Malaysia?
Provide a short and direct response. 0.38. In the year 2005, what is the difference between the Rent(as % of GDP) in Honduras and Rent(as % of GDP) in Slovak Republic?
Offer a terse response. 0.4. In the year 2005, what is the difference between the Rent(as % of GDP) of Malaysia and Rent(as % of GDP) of Slovak Republic?
Provide a succinct answer. 0.02. In the year 2006, what is the difference between the Rent(as % of GDP) in Greece and Rent(as % of GDP) in Honduras?
Provide a short and direct response. -1.11. In the year 2006, what is the difference between the Rent(as % of GDP) in Greece and Rent(as % of GDP) in Malaysia?
Offer a terse response. 0.11. In the year 2006, what is the difference between the Rent(as % of GDP) in Greece and Rent(as % of GDP) in Slovak Republic?
Ensure brevity in your answer.  0.13. In the year 2006, what is the difference between the Rent(as % of GDP) in Honduras and Rent(as % of GDP) in Malaysia?
Ensure brevity in your answer.  1.22. In the year 2006, what is the difference between the Rent(as % of GDP) of Honduras and Rent(as % of GDP) of Slovak Republic?
Offer a terse response. 1.24. In the year 2006, what is the difference between the Rent(as % of GDP) of Malaysia and Rent(as % of GDP) of Slovak Republic?
Make the answer very short. 0.02. In the year 2007, what is the difference between the Rent(as % of GDP) of Greece and Rent(as % of GDP) of Honduras?
Give a very brief answer. -0.8. In the year 2007, what is the difference between the Rent(as % of GDP) in Greece and Rent(as % of GDP) in Malaysia?
Ensure brevity in your answer.  0.19. In the year 2007, what is the difference between the Rent(as % of GDP) in Greece and Rent(as % of GDP) in Slovak Republic?
Make the answer very short. 0.19. In the year 2007, what is the difference between the Rent(as % of GDP) in Honduras and Rent(as % of GDP) in Malaysia?
Provide a succinct answer. 0.99. In the year 2007, what is the difference between the Rent(as % of GDP) in Honduras and Rent(as % of GDP) in Slovak Republic?
Provide a short and direct response. 0.99. In the year 2007, what is the difference between the Rent(as % of GDP) in Malaysia and Rent(as % of GDP) in Slovak Republic?
Your response must be concise. 0. In the year 2008, what is the difference between the Rent(as % of GDP) of Greece and Rent(as % of GDP) of Honduras?
Give a very brief answer. -0.55. In the year 2008, what is the difference between the Rent(as % of GDP) in Greece and Rent(as % of GDP) in Malaysia?
Offer a terse response. 0.04. In the year 2008, what is the difference between the Rent(as % of GDP) in Greece and Rent(as % of GDP) in Slovak Republic?
Your response must be concise. 0.07. In the year 2008, what is the difference between the Rent(as % of GDP) of Honduras and Rent(as % of GDP) of Malaysia?
Your response must be concise. 0.59. In the year 2008, what is the difference between the Rent(as % of GDP) in Honduras and Rent(as % of GDP) in Slovak Republic?
Provide a succinct answer. 0.62. In the year 2008, what is the difference between the Rent(as % of GDP) of Malaysia and Rent(as % of GDP) of Slovak Republic?
Make the answer very short. 0.03. In the year 2009, what is the difference between the Rent(as % of GDP) of Greece and Rent(as % of GDP) of Honduras?
Your response must be concise. -0.58. In the year 2009, what is the difference between the Rent(as % of GDP) in Greece and Rent(as % of GDP) in Malaysia?
Ensure brevity in your answer.  -0.02. In the year 2009, what is the difference between the Rent(as % of GDP) in Greece and Rent(as % of GDP) in Slovak Republic?
Provide a succinct answer. 0.04. In the year 2009, what is the difference between the Rent(as % of GDP) in Honduras and Rent(as % of GDP) in Malaysia?
Provide a short and direct response. 0.55. In the year 2009, what is the difference between the Rent(as % of GDP) of Honduras and Rent(as % of GDP) of Slovak Republic?
Ensure brevity in your answer.  0.61. In the year 2009, what is the difference between the Rent(as % of GDP) of Malaysia and Rent(as % of GDP) of Slovak Republic?
Keep it short and to the point. 0.06. In the year 2010, what is the difference between the Rent(as % of GDP) of Greece and Rent(as % of GDP) of Honduras?
Make the answer very short. -0.72. In the year 2010, what is the difference between the Rent(as % of GDP) in Greece and Rent(as % of GDP) in Malaysia?
Your response must be concise. -0.07. In the year 2010, what is the difference between the Rent(as % of GDP) of Greece and Rent(as % of GDP) of Slovak Republic?
Your answer should be compact. 0.12. In the year 2010, what is the difference between the Rent(as % of GDP) in Honduras and Rent(as % of GDP) in Malaysia?
Make the answer very short. 0.64. In the year 2010, what is the difference between the Rent(as % of GDP) in Honduras and Rent(as % of GDP) in Slovak Republic?
Ensure brevity in your answer.  0.84. In the year 2010, what is the difference between the Rent(as % of GDP) in Malaysia and Rent(as % of GDP) in Slovak Republic?
Offer a very short reply. 0.19. In the year 2011, what is the difference between the Rent(as % of GDP) in Greece and Rent(as % of GDP) in Honduras?
Your response must be concise. -0.76. In the year 2011, what is the difference between the Rent(as % of GDP) in Greece and Rent(as % of GDP) in Malaysia?
Make the answer very short. -0.25. In the year 2011, what is the difference between the Rent(as % of GDP) in Greece and Rent(as % of GDP) in Slovak Republic?
Your answer should be very brief. 0.15. In the year 2011, what is the difference between the Rent(as % of GDP) of Honduras and Rent(as % of GDP) of Malaysia?
Ensure brevity in your answer.  0.51. In the year 2011, what is the difference between the Rent(as % of GDP) in Honduras and Rent(as % of GDP) in Slovak Republic?
Offer a terse response. 0.91. In the year 2011, what is the difference between the Rent(as % of GDP) of Malaysia and Rent(as % of GDP) of Slovak Republic?
Provide a succinct answer. 0.4. What is the ratio of the Rent(as % of GDP) in Greece in 2004 to that in 2005?
Your answer should be very brief. 0.67. What is the ratio of the Rent(as % of GDP) in Honduras in 2004 to that in 2005?
Provide a short and direct response. 0.55. What is the ratio of the Rent(as % of GDP) of Malaysia in 2004 to that in 2005?
Make the answer very short. 0.58. What is the ratio of the Rent(as % of GDP) of Slovak Republic in 2004 to that in 2005?
Offer a terse response. 0.06. What is the ratio of the Rent(as % of GDP) of Greece in 2004 to that in 2006?
Your answer should be compact. 0.32. What is the ratio of the Rent(as % of GDP) of Honduras in 2004 to that in 2006?
Give a very brief answer. 0.19. What is the ratio of the Rent(as % of GDP) of Malaysia in 2004 to that in 2006?
Your response must be concise. 0.6. What is the ratio of the Rent(as % of GDP) in Slovak Republic in 2004 to that in 2006?
Ensure brevity in your answer.  0.06. What is the ratio of the Rent(as % of GDP) of Greece in 2004 to that in 2007?
Ensure brevity in your answer.  0.2. What is the ratio of the Rent(as % of GDP) of Honduras in 2004 to that in 2007?
Your answer should be very brief. 0.22. What is the ratio of the Rent(as % of GDP) of Malaysia in 2004 to that in 2007?
Your answer should be very brief. 0.42. What is the ratio of the Rent(as % of GDP) of Slovak Republic in 2004 to that in 2007?
Your response must be concise. 0.03. What is the ratio of the Rent(as % of GDP) of Greece in 2004 to that in 2008?
Your answer should be compact. 0.44. What is the ratio of the Rent(as % of GDP) in Honduras in 2004 to that in 2008?
Your response must be concise. 0.35. What is the ratio of the Rent(as % of GDP) of Malaysia in 2004 to that in 2008?
Ensure brevity in your answer.  0.35. What is the ratio of the Rent(as % of GDP) of Slovak Republic in 2004 to that in 2008?
Make the answer very short. 0.03. What is the ratio of the Rent(as % of GDP) of Greece in 2004 to that in 2009?
Provide a succinct answer. 1.15. What is the ratio of the Rent(as % of GDP) of Honduras in 2004 to that in 2009?
Provide a succinct answer. 0.38. What is the ratio of the Rent(as % of GDP) of Malaysia in 2004 to that in 2009?
Give a very brief answer. 0.37. What is the ratio of the Rent(as % of GDP) of Slovak Republic in 2004 to that in 2009?
Your answer should be compact. 0.18. What is the ratio of the Rent(as % of GDP) in Greece in 2004 to that in 2010?
Give a very brief answer. 0.38. What is the ratio of the Rent(as % of GDP) of Honduras in 2004 to that in 2010?
Make the answer very short. 0.28. What is the ratio of the Rent(as % of GDP) of Malaysia in 2004 to that in 2010?
Keep it short and to the point. 0.12. What is the ratio of the Rent(as % of GDP) in Slovak Republic in 2004 to that in 2010?
Ensure brevity in your answer.  0.14. What is the ratio of the Rent(as % of GDP) in Greece in 2004 to that in 2011?
Make the answer very short. 0.3. What is the ratio of the Rent(as % of GDP) of Honduras in 2004 to that in 2011?
Your response must be concise. 0.25. What is the ratio of the Rent(as % of GDP) of Malaysia in 2004 to that in 2011?
Offer a very short reply. 0.06. What is the ratio of the Rent(as % of GDP) of Slovak Republic in 2004 to that in 2011?
Offer a very short reply. 0.12. What is the ratio of the Rent(as % of GDP) in Greece in 2005 to that in 2006?
Ensure brevity in your answer.  0.49. What is the ratio of the Rent(as % of GDP) in Honduras in 2005 to that in 2006?
Your answer should be very brief. 0.34. What is the ratio of the Rent(as % of GDP) of Malaysia in 2005 to that in 2006?
Your answer should be very brief. 1.04. What is the ratio of the Rent(as % of GDP) of Slovak Republic in 2005 to that in 2006?
Give a very brief answer. 0.9. What is the ratio of the Rent(as % of GDP) of Greece in 2005 to that in 2007?
Make the answer very short. 0.31. What is the ratio of the Rent(as % of GDP) of Honduras in 2005 to that in 2007?
Provide a succinct answer. 0.4. What is the ratio of the Rent(as % of GDP) of Malaysia in 2005 to that in 2007?
Ensure brevity in your answer.  0.73. What is the ratio of the Rent(as % of GDP) in Slovak Republic in 2005 to that in 2007?
Keep it short and to the point. 0.42. What is the ratio of the Rent(as % of GDP) of Greece in 2005 to that in 2008?
Keep it short and to the point. 0.66. What is the ratio of the Rent(as % of GDP) in Honduras in 2005 to that in 2008?
Offer a very short reply. 0.64. What is the ratio of the Rent(as % of GDP) in Malaysia in 2005 to that in 2008?
Ensure brevity in your answer.  0.6. What is the ratio of the Rent(as % of GDP) in Slovak Republic in 2005 to that in 2008?
Give a very brief answer. 0.52. What is the ratio of the Rent(as % of GDP) of Greece in 2005 to that in 2009?
Your answer should be compact. 1.72. What is the ratio of the Rent(as % of GDP) in Honduras in 2005 to that in 2009?
Offer a very short reply. 0.68. What is the ratio of the Rent(as % of GDP) of Malaysia in 2005 to that in 2009?
Provide a succinct answer. 0.65. What is the ratio of the Rent(as % of GDP) of Slovak Republic in 2005 to that in 2009?
Your answer should be very brief. 2.93. What is the ratio of the Rent(as % of GDP) in Greece in 2005 to that in 2010?
Your response must be concise. 0.56. What is the ratio of the Rent(as % of GDP) of Malaysia in 2005 to that in 2010?
Provide a succinct answer. 0.21. What is the ratio of the Rent(as % of GDP) of Slovak Republic in 2005 to that in 2010?
Your answer should be very brief. 2.17. What is the ratio of the Rent(as % of GDP) in Greece in 2005 to that in 2011?
Provide a succinct answer. 0.45. What is the ratio of the Rent(as % of GDP) of Honduras in 2005 to that in 2011?
Your answer should be very brief. 0.46. What is the ratio of the Rent(as % of GDP) in Malaysia in 2005 to that in 2011?
Offer a terse response. 0.11. What is the ratio of the Rent(as % of GDP) of Slovak Republic in 2005 to that in 2011?
Keep it short and to the point. 1.99. What is the ratio of the Rent(as % of GDP) of Greece in 2006 to that in 2007?
Ensure brevity in your answer.  0.63. What is the ratio of the Rent(as % of GDP) of Honduras in 2006 to that in 2007?
Your answer should be very brief. 1.2. What is the ratio of the Rent(as % of GDP) in Malaysia in 2006 to that in 2007?
Make the answer very short. 0.7. What is the ratio of the Rent(as % of GDP) in Slovak Republic in 2006 to that in 2007?
Your answer should be very brief. 0.46. What is the ratio of the Rent(as % of GDP) in Greece in 2006 to that in 2008?
Your answer should be very brief. 1.37. What is the ratio of the Rent(as % of GDP) of Honduras in 2006 to that in 2008?
Keep it short and to the point. 1.91. What is the ratio of the Rent(as % of GDP) in Malaysia in 2006 to that in 2008?
Provide a short and direct response. 0.58. What is the ratio of the Rent(as % of GDP) in Slovak Republic in 2006 to that in 2008?
Your answer should be very brief. 0.57. What is the ratio of the Rent(as % of GDP) in Greece in 2006 to that in 2009?
Offer a very short reply. 3.55. What is the ratio of the Rent(as % of GDP) of Honduras in 2006 to that in 2009?
Your answer should be very brief. 2.03. What is the ratio of the Rent(as % of GDP) of Malaysia in 2006 to that in 2009?
Ensure brevity in your answer.  0.62. What is the ratio of the Rent(as % of GDP) of Slovak Republic in 2006 to that in 2009?
Provide a short and direct response. 3.23. What is the ratio of the Rent(as % of GDP) in Greece in 2006 to that in 2010?
Your answer should be very brief. 1.16. What is the ratio of the Rent(as % of GDP) of Honduras in 2006 to that in 2010?
Offer a very short reply. 1.49. What is the ratio of the Rent(as % of GDP) in Malaysia in 2006 to that in 2010?
Offer a terse response. 0.21. What is the ratio of the Rent(as % of GDP) in Slovak Republic in 2006 to that in 2010?
Provide a short and direct response. 2.4. What is the ratio of the Rent(as % of GDP) of Greece in 2006 to that in 2011?
Give a very brief answer. 0.93. What is the ratio of the Rent(as % of GDP) in Honduras in 2006 to that in 2011?
Provide a succinct answer. 1.37. What is the ratio of the Rent(as % of GDP) in Malaysia in 2006 to that in 2011?
Offer a very short reply. 0.1. What is the ratio of the Rent(as % of GDP) in Slovak Republic in 2006 to that in 2011?
Offer a very short reply. 2.2. What is the ratio of the Rent(as % of GDP) in Greece in 2007 to that in 2008?
Keep it short and to the point. 2.17. What is the ratio of the Rent(as % of GDP) in Honduras in 2007 to that in 2008?
Ensure brevity in your answer.  1.59. What is the ratio of the Rent(as % of GDP) of Malaysia in 2007 to that in 2008?
Your response must be concise. 0.82. What is the ratio of the Rent(as % of GDP) in Slovak Republic in 2007 to that in 2008?
Keep it short and to the point. 1.25. What is the ratio of the Rent(as % of GDP) in Greece in 2007 to that in 2009?
Your response must be concise. 5.64. What is the ratio of the Rent(as % of GDP) in Honduras in 2007 to that in 2009?
Offer a very short reply. 1.69. What is the ratio of the Rent(as % of GDP) of Malaysia in 2007 to that in 2009?
Make the answer very short. 0.89. What is the ratio of the Rent(as % of GDP) in Slovak Republic in 2007 to that in 2009?
Your answer should be compact. 7.05. What is the ratio of the Rent(as % of GDP) in Greece in 2007 to that in 2010?
Ensure brevity in your answer.  1.84. What is the ratio of the Rent(as % of GDP) of Honduras in 2007 to that in 2010?
Make the answer very short. 1.24. What is the ratio of the Rent(as % of GDP) of Malaysia in 2007 to that in 2010?
Keep it short and to the point. 0.29. What is the ratio of the Rent(as % of GDP) in Slovak Republic in 2007 to that in 2010?
Ensure brevity in your answer.  5.24. What is the ratio of the Rent(as % of GDP) of Greece in 2007 to that in 2011?
Offer a terse response. 1.48. What is the ratio of the Rent(as % of GDP) of Honduras in 2007 to that in 2011?
Provide a short and direct response. 1.14. What is the ratio of the Rent(as % of GDP) of Malaysia in 2007 to that in 2011?
Provide a succinct answer. 0.15. What is the ratio of the Rent(as % of GDP) of Slovak Republic in 2007 to that in 2011?
Provide a succinct answer. 4.79. What is the ratio of the Rent(as % of GDP) in Greece in 2008 to that in 2009?
Provide a succinct answer. 2.6. What is the ratio of the Rent(as % of GDP) in Honduras in 2008 to that in 2009?
Your answer should be compact. 1.06. What is the ratio of the Rent(as % of GDP) in Malaysia in 2008 to that in 2009?
Provide a succinct answer. 1.08. What is the ratio of the Rent(as % of GDP) of Slovak Republic in 2008 to that in 2009?
Give a very brief answer. 5.63. What is the ratio of the Rent(as % of GDP) of Greece in 2008 to that in 2010?
Provide a short and direct response. 0.85. What is the ratio of the Rent(as % of GDP) in Honduras in 2008 to that in 2010?
Your answer should be very brief. 0.78. What is the ratio of the Rent(as % of GDP) of Malaysia in 2008 to that in 2010?
Ensure brevity in your answer.  0.36. What is the ratio of the Rent(as % of GDP) of Slovak Republic in 2008 to that in 2010?
Offer a very short reply. 4.18. What is the ratio of the Rent(as % of GDP) in Greece in 2008 to that in 2011?
Offer a terse response. 0.68. What is the ratio of the Rent(as % of GDP) of Honduras in 2008 to that in 2011?
Your answer should be compact. 0.72. What is the ratio of the Rent(as % of GDP) in Malaysia in 2008 to that in 2011?
Your answer should be compact. 0.18. What is the ratio of the Rent(as % of GDP) in Slovak Republic in 2008 to that in 2011?
Offer a very short reply. 3.83. What is the ratio of the Rent(as % of GDP) in Greece in 2009 to that in 2010?
Make the answer very short. 0.33. What is the ratio of the Rent(as % of GDP) of Honduras in 2009 to that in 2010?
Give a very brief answer. 0.73. What is the ratio of the Rent(as % of GDP) in Malaysia in 2009 to that in 2010?
Your answer should be compact. 0.33. What is the ratio of the Rent(as % of GDP) of Slovak Republic in 2009 to that in 2010?
Your answer should be compact. 0.74. What is the ratio of the Rent(as % of GDP) in Greece in 2009 to that in 2011?
Keep it short and to the point. 0.26. What is the ratio of the Rent(as % of GDP) of Honduras in 2009 to that in 2011?
Your response must be concise. 0.67. What is the ratio of the Rent(as % of GDP) of Malaysia in 2009 to that in 2011?
Your response must be concise. 0.16. What is the ratio of the Rent(as % of GDP) of Slovak Republic in 2009 to that in 2011?
Your answer should be very brief. 0.68. What is the ratio of the Rent(as % of GDP) in Greece in 2010 to that in 2011?
Keep it short and to the point. 0.8. What is the ratio of the Rent(as % of GDP) in Honduras in 2010 to that in 2011?
Offer a terse response. 0.92. What is the ratio of the Rent(as % of GDP) in Malaysia in 2010 to that in 2011?
Your answer should be compact. 0.5. What is the ratio of the Rent(as % of GDP) of Slovak Republic in 2010 to that in 2011?
Make the answer very short. 0.92. What is the difference between the highest and the second highest Rent(as % of GDP) of Greece?
Give a very brief answer. 0.08. What is the difference between the highest and the second highest Rent(as % of GDP) in Honduras?
Make the answer very short. 0.21. What is the difference between the highest and the second highest Rent(as % of GDP) of Malaysia?
Your answer should be compact. 0.21. What is the difference between the highest and the second highest Rent(as % of GDP) in Slovak Republic?
Provide a succinct answer. 0.01. What is the difference between the highest and the lowest Rent(as % of GDP) in Greece?
Your response must be concise. 0.2. What is the difference between the highest and the lowest Rent(as % of GDP) in Honduras?
Provide a short and direct response. 1.03. What is the difference between the highest and the lowest Rent(as % of GDP) in Malaysia?
Offer a terse response. 0.39. What is the difference between the highest and the lowest Rent(as % of GDP) in Slovak Republic?
Provide a short and direct response. 0.06. 